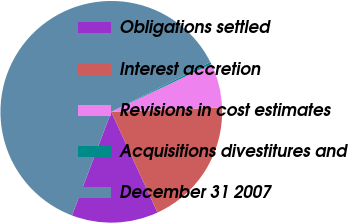Convert chart to OTSL. <chart><loc_0><loc_0><loc_500><loc_500><pie_chart><fcel>Obligations settled<fcel>Interest accretion<fcel>Revisions in cost estimates<fcel>Acquisitions divestitures and<fcel>December 31 2007<nl><fcel>12.62%<fcel>18.77%<fcel>6.47%<fcel>0.31%<fcel>61.83%<nl></chart> 